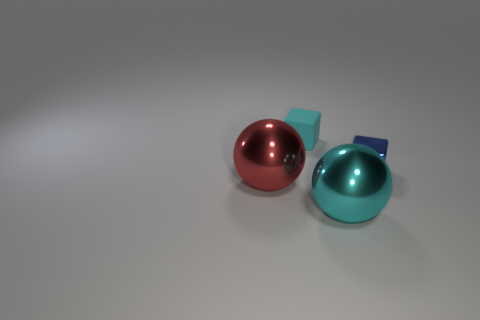Is there any other thing that has the same material as the tiny cyan cube?
Your answer should be very brief. No. What number of large balls have the same color as the small rubber block?
Provide a short and direct response. 1. Do the object right of the cyan shiny sphere and the tiny object left of the metal cube have the same shape?
Provide a short and direct response. Yes. There is a big thing to the right of the large red object left of the small cube on the left side of the tiny blue metal cube; what color is it?
Your answer should be compact. Cyan. What color is the large ball to the left of the large cyan metal ball?
Keep it short and to the point. Red. The other metallic thing that is the same size as the red metallic object is what color?
Provide a short and direct response. Cyan. Do the red metallic sphere and the blue metallic object have the same size?
Your answer should be compact. No. What number of cyan spheres are right of the blue object?
Offer a very short reply. 0. How many things are either cyan things that are behind the cyan ball or red objects?
Your answer should be compact. 2. Are there more metallic balls that are on the right side of the cyan cube than big cyan metal balls in front of the small shiny thing?
Provide a short and direct response. No. 